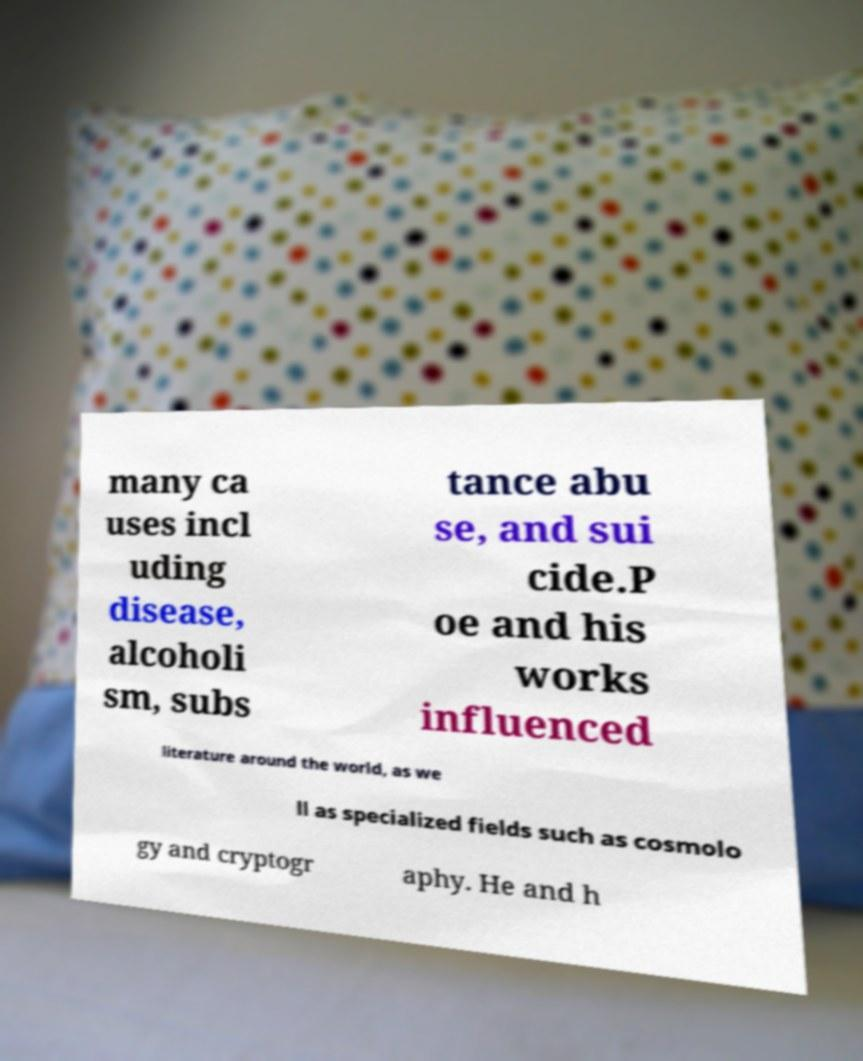Could you extract and type out the text from this image? many ca uses incl uding disease, alcoholi sm, subs tance abu se, and sui cide.P oe and his works influenced literature around the world, as we ll as specialized fields such as cosmolo gy and cryptogr aphy. He and h 